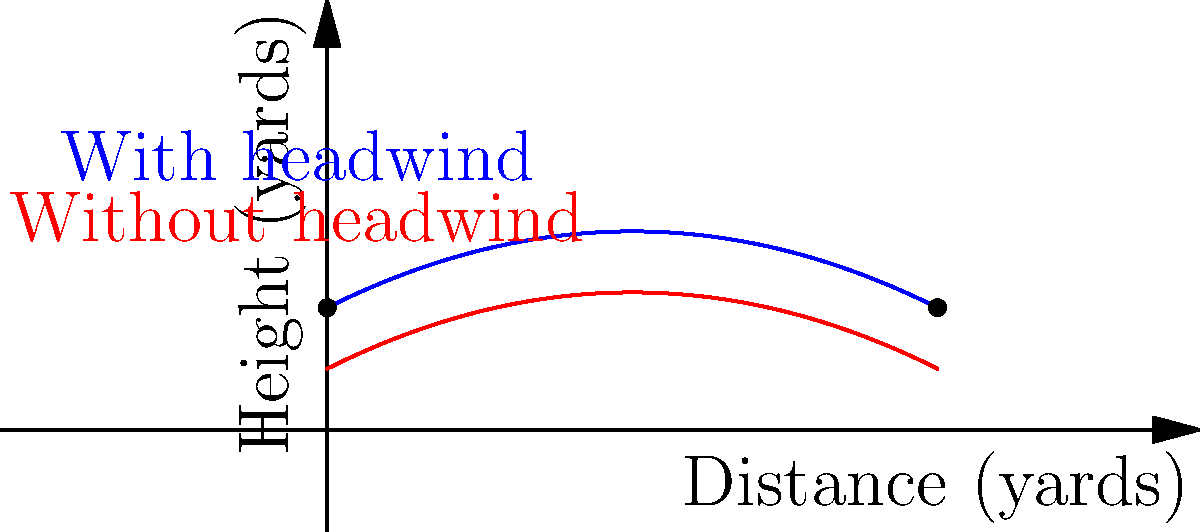As the coach of a North Carolina high school football team, you're teaching your quarterback about the effects of wind on passing. The graph shows the trajectory of a football pass with and without a headwind. If the pass travels 10 yards downfield, approximately how much lower does the ball's maximum height become when thrown into a headwind compared to no wind? To solve this problem, let's follow these steps:

1) The blue curve represents the trajectory with a headwind, while the red curve shows the trajectory without wind.

2) We need to find the maximum height of each curve and calculate the difference.

3) For the curve without wind (red):
   - The maximum height occurs at approximately the midpoint of the pass (5 yards).
   - By estimating from the graph, the maximum height is about 4.25 yards.

4) For the curve with headwind (blue):
   - The maximum height also occurs around the midpoint.
   - By estimating from the graph, the maximum height is about 3.75 yards.

5) To find the difference in maximum height:
   $4.25 \text{ yards} - 3.75 \text{ yards} = 0.5 \text{ yards}$

6) Convert yards to feet:
   $0.5 \text{ yards} \times 3 \text{ feet/yard} = 1.5 \text{ feet}$

Therefore, the ball's maximum height is approximately 1.5 feet lower when thrown into a headwind compared to no wind.
Answer: 1.5 feet 